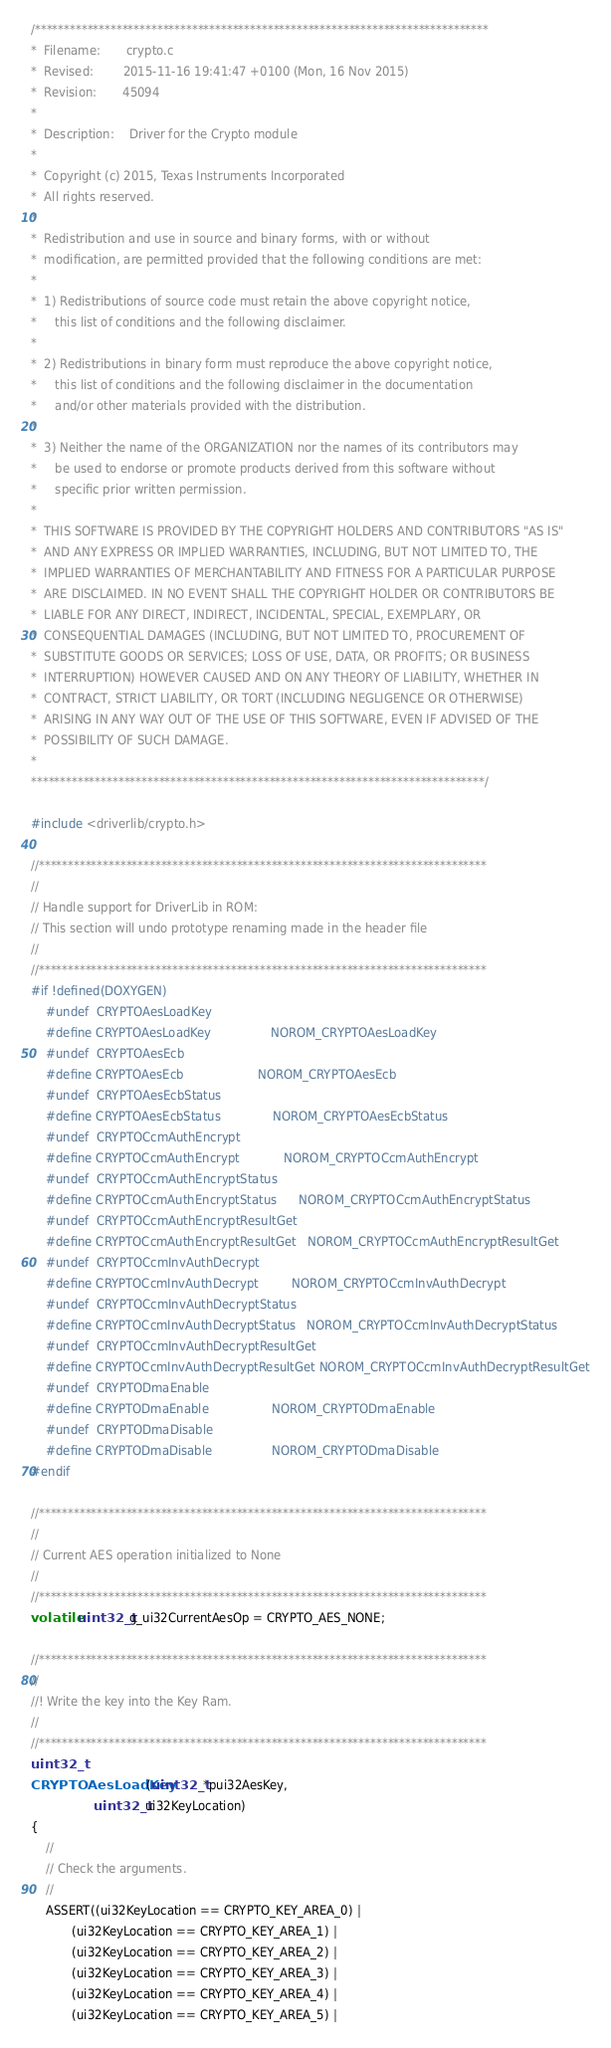<code> <loc_0><loc_0><loc_500><loc_500><_C_>/******************************************************************************
*  Filename:       crypto.c
*  Revised:        2015-11-16 19:41:47 +0100 (Mon, 16 Nov 2015)
*  Revision:       45094
*
*  Description:    Driver for the Crypto module
*
*  Copyright (c) 2015, Texas Instruments Incorporated
*  All rights reserved.
*
*  Redistribution and use in source and binary forms, with or without
*  modification, are permitted provided that the following conditions are met:
*
*  1) Redistributions of source code must retain the above copyright notice,
*     this list of conditions and the following disclaimer.
*
*  2) Redistributions in binary form must reproduce the above copyright notice,
*     this list of conditions and the following disclaimer in the documentation
*     and/or other materials provided with the distribution.
*
*  3) Neither the name of the ORGANIZATION nor the names of its contributors may
*     be used to endorse or promote products derived from this software without
*     specific prior written permission.
*
*  THIS SOFTWARE IS PROVIDED BY THE COPYRIGHT HOLDERS AND CONTRIBUTORS "AS IS"
*  AND ANY EXPRESS OR IMPLIED WARRANTIES, INCLUDING, BUT NOT LIMITED TO, THE
*  IMPLIED WARRANTIES OF MERCHANTABILITY AND FITNESS FOR A PARTICULAR PURPOSE
*  ARE DISCLAIMED. IN NO EVENT SHALL THE COPYRIGHT HOLDER OR CONTRIBUTORS BE
*  LIABLE FOR ANY DIRECT, INDIRECT, INCIDENTAL, SPECIAL, EXEMPLARY, OR
*  CONSEQUENTIAL DAMAGES (INCLUDING, BUT NOT LIMITED TO, PROCUREMENT OF
*  SUBSTITUTE GOODS OR SERVICES; LOSS OF USE, DATA, OR PROFITS; OR BUSINESS
*  INTERRUPTION) HOWEVER CAUSED AND ON ANY THEORY OF LIABILITY, WHETHER IN
*  CONTRACT, STRICT LIABILITY, OR TORT (INCLUDING NEGLIGENCE OR OTHERWISE)
*  ARISING IN ANY WAY OUT OF THE USE OF THIS SOFTWARE, EVEN IF ADVISED OF THE
*  POSSIBILITY OF SUCH DAMAGE.
*
******************************************************************************/

#include <driverlib/crypto.h>

//*****************************************************************************
//
// Handle support for DriverLib in ROM:
// This section will undo prototype renaming made in the header file
//
//*****************************************************************************
#if !defined(DOXYGEN)
    #undef  CRYPTOAesLoadKey
    #define CRYPTOAesLoadKey                NOROM_CRYPTOAesLoadKey
    #undef  CRYPTOAesEcb
    #define CRYPTOAesEcb                    NOROM_CRYPTOAesEcb
    #undef  CRYPTOAesEcbStatus
    #define CRYPTOAesEcbStatus              NOROM_CRYPTOAesEcbStatus
    #undef  CRYPTOCcmAuthEncrypt
    #define CRYPTOCcmAuthEncrypt            NOROM_CRYPTOCcmAuthEncrypt
    #undef  CRYPTOCcmAuthEncryptStatus
    #define CRYPTOCcmAuthEncryptStatus      NOROM_CRYPTOCcmAuthEncryptStatus
    #undef  CRYPTOCcmAuthEncryptResultGet
    #define CRYPTOCcmAuthEncryptResultGet   NOROM_CRYPTOCcmAuthEncryptResultGet
    #undef  CRYPTOCcmInvAuthDecrypt
    #define CRYPTOCcmInvAuthDecrypt         NOROM_CRYPTOCcmInvAuthDecrypt
    #undef  CRYPTOCcmInvAuthDecryptStatus
    #define CRYPTOCcmInvAuthDecryptStatus   NOROM_CRYPTOCcmInvAuthDecryptStatus
    #undef  CRYPTOCcmInvAuthDecryptResultGet
    #define CRYPTOCcmInvAuthDecryptResultGet NOROM_CRYPTOCcmInvAuthDecryptResultGet
    #undef  CRYPTODmaEnable
    #define CRYPTODmaEnable                 NOROM_CRYPTODmaEnable
    #undef  CRYPTODmaDisable
    #define CRYPTODmaDisable                NOROM_CRYPTODmaDisable
#endif

//*****************************************************************************
//
// Current AES operation initialized to None
//
//*****************************************************************************
volatile uint32_t g_ui32CurrentAesOp = CRYPTO_AES_NONE;

//*****************************************************************************
//
//! Write the key into the Key Ram.
//
//*****************************************************************************
uint32_t
CRYPTOAesLoadKey(uint32_t *pui32AesKey,
                 uint32_t ui32KeyLocation)
{
    //
    // Check the arguments.
    //
    ASSERT((ui32KeyLocation == CRYPTO_KEY_AREA_0) |
           (ui32KeyLocation == CRYPTO_KEY_AREA_1) |
           (ui32KeyLocation == CRYPTO_KEY_AREA_2) |
           (ui32KeyLocation == CRYPTO_KEY_AREA_3) |
           (ui32KeyLocation == CRYPTO_KEY_AREA_4) |
           (ui32KeyLocation == CRYPTO_KEY_AREA_5) |</code> 